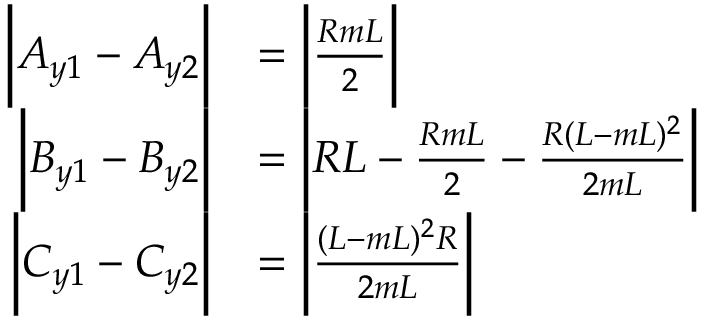<formula> <loc_0><loc_0><loc_500><loc_500>\begin{array} { r l } { \left | A _ { y 1 } - A _ { y 2 } \right | } & { = \left | \frac { R m L } { 2 } \right | } \\ { \left | B _ { y 1 } - B _ { y 2 } \right | } & { = \left | R L - \frac { R m L } { 2 } - \frac { R ( L - m L ) ^ { 2 } } { 2 m L } \right | } \\ { \left | C _ { y 1 } - C _ { y 2 } \right | } & { = \left | \frac { ( L - m L ) ^ { 2 } R } { 2 m L } \right | } \end{array}</formula> 